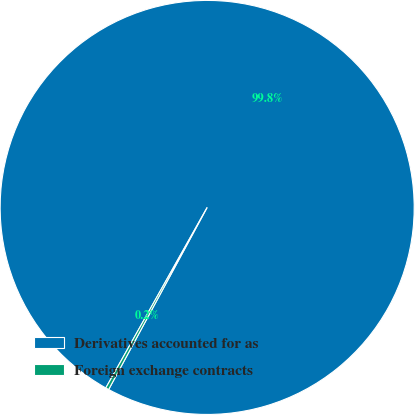Convert chart to OTSL. <chart><loc_0><loc_0><loc_500><loc_500><pie_chart><fcel>Derivatives accounted for as<fcel>Foreign exchange contracts<nl><fcel>99.75%<fcel>0.25%<nl></chart> 